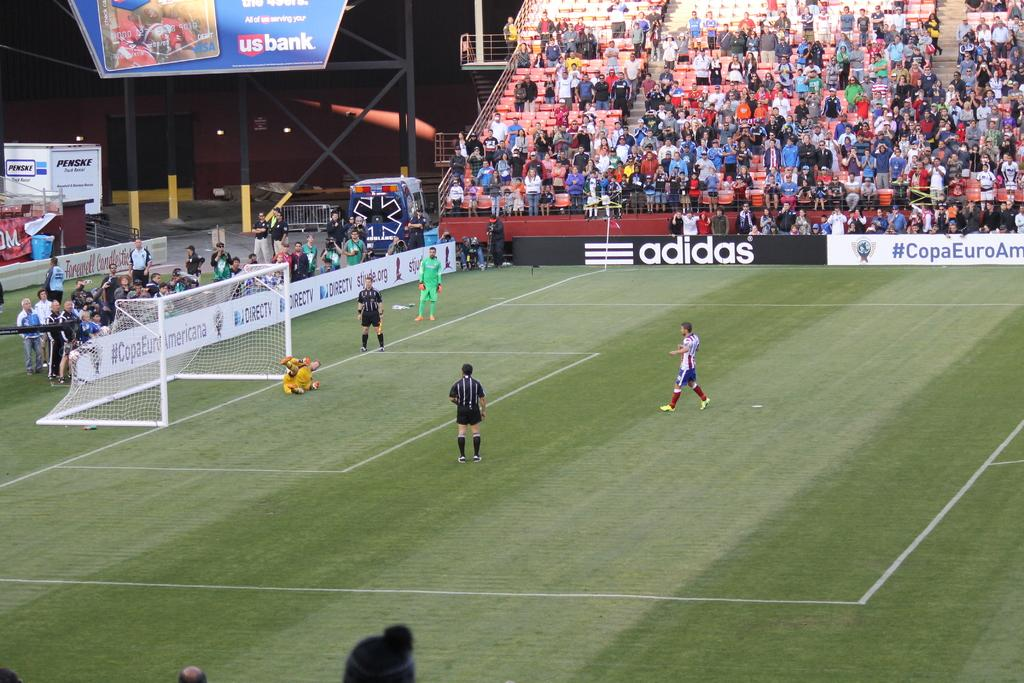<image>
Present a compact description of the photo's key features. A soccer field with an adidas advertisement in the back 